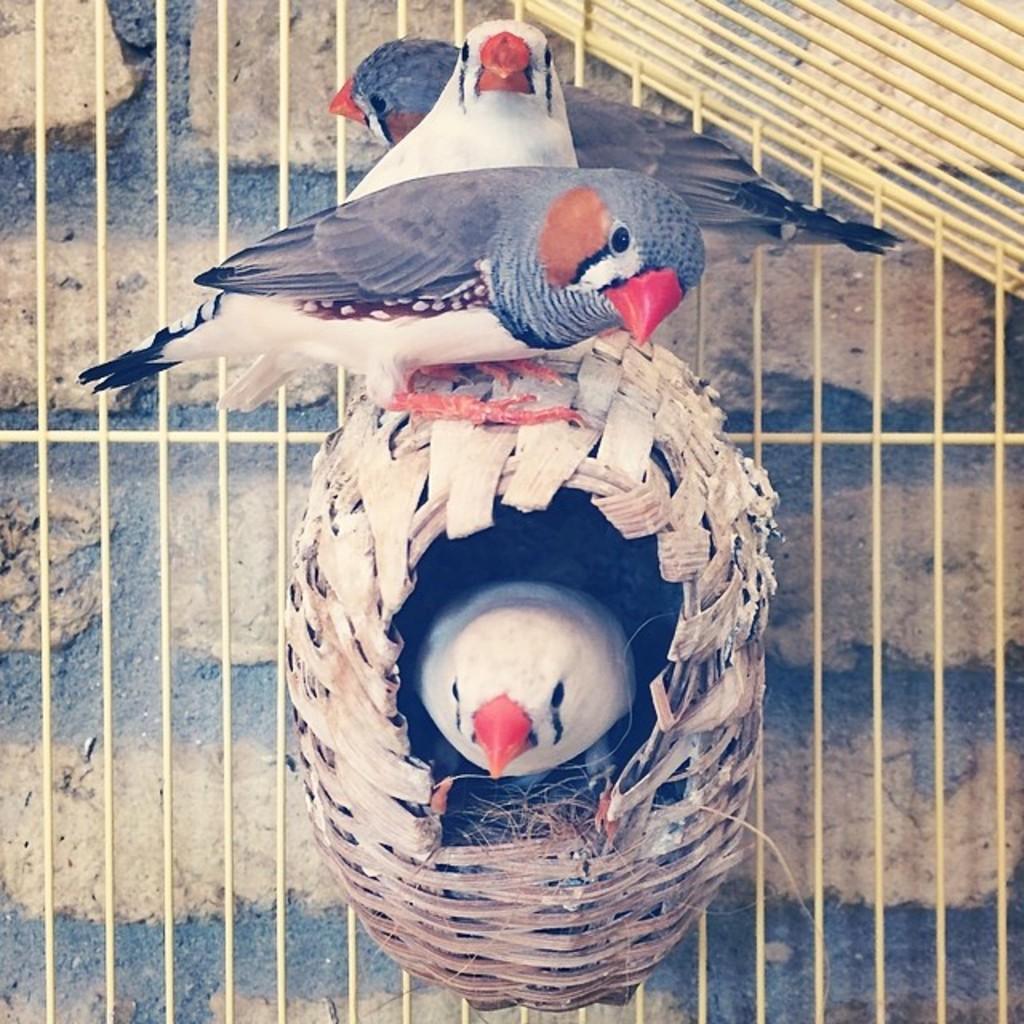Describe this image in one or two sentences. In this picture I can see few birds are standing on the nest, one bird is inside the next. 